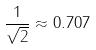<formula> <loc_0><loc_0><loc_500><loc_500>\frac { 1 } { \sqrt { 2 } } \approx 0 . 7 0 7</formula> 